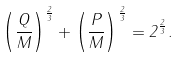Convert formula to latex. <formula><loc_0><loc_0><loc_500><loc_500>\left ( { \frac { Q } { M } } \right ) ^ { \frac { 2 } { 3 } } + \left ( { \frac { P } { M } } \right ) ^ { \frac { 2 } { 3 } } = 2 ^ { \frac { 2 } { 3 } } .</formula> 